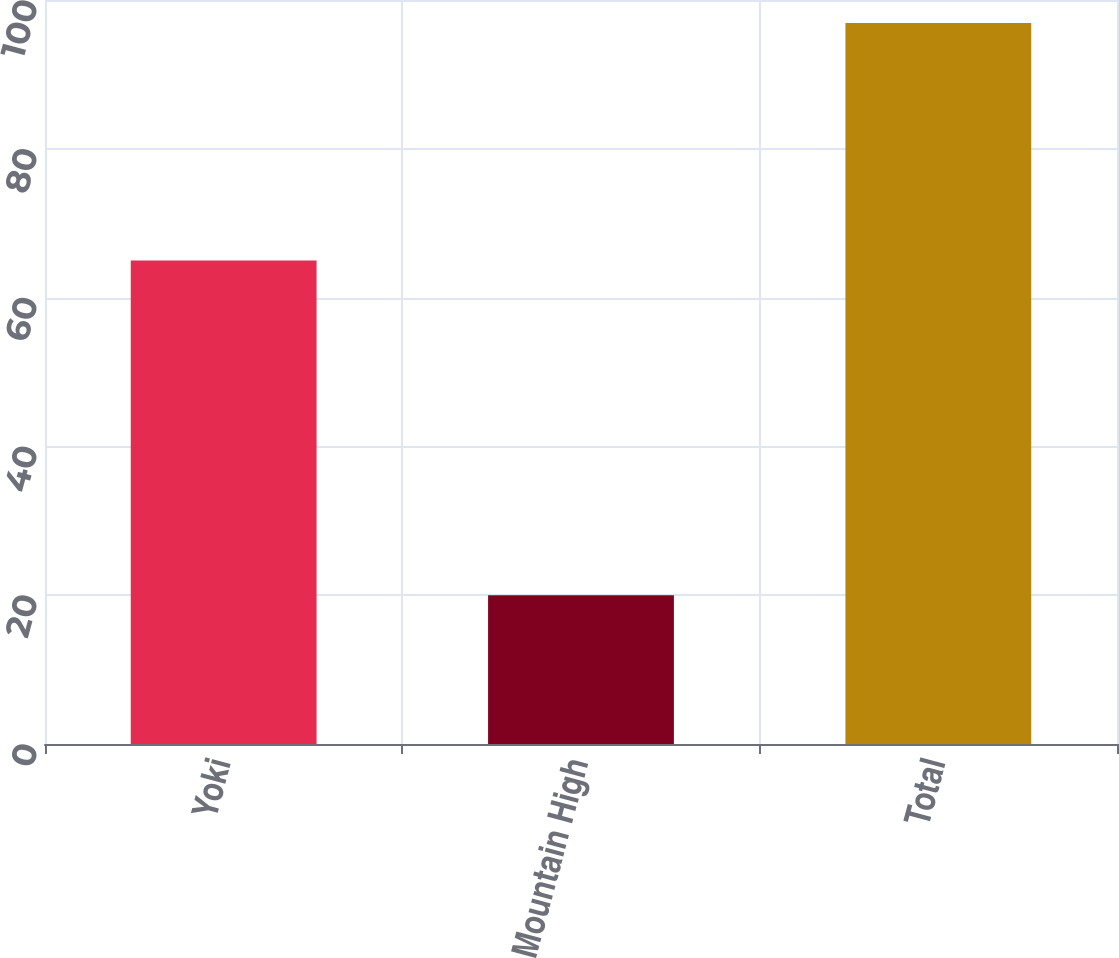Convert chart to OTSL. <chart><loc_0><loc_0><loc_500><loc_500><bar_chart><fcel>Yoki<fcel>Mountain High<fcel>Total<nl><fcel>65<fcel>20<fcel>96.9<nl></chart> 